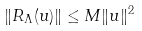<formula> <loc_0><loc_0><loc_500><loc_500>\| R _ { \Lambda } ( u ) \| \leq M \| u \| ^ { 2 }</formula> 